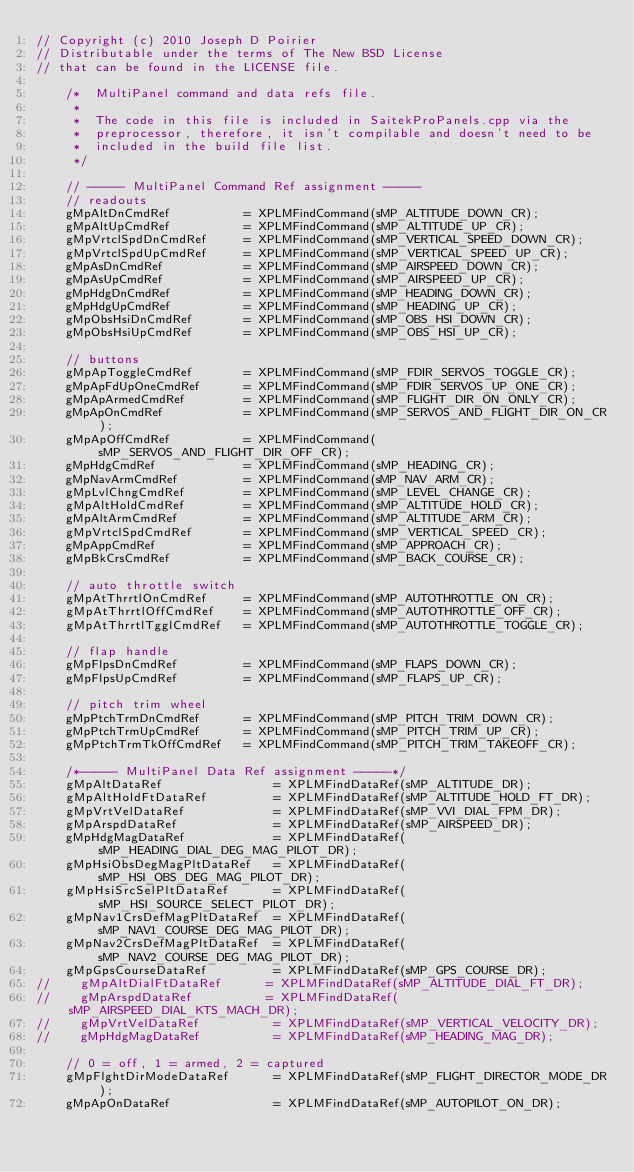<code> <loc_0><loc_0><loc_500><loc_500><_C++_>// Copyright (c) 2010 Joseph D Poirier
// Distributable under the terms of The New BSD License
// that can be found in the LICENSE file.

    /*  MultiPanel command and data refs file.
     *
     *  The code in this file is included in SaitekProPanels.cpp via the
     *  preprocessor, therefore, it isn't compilable and doesn't need to be
     *  included in the build file list.
     */

    // ----- MultiPanel Command Ref assignment -----
    // readouts
    gMpAltDnCmdRef          = XPLMFindCommand(sMP_ALTITUDE_DOWN_CR);
    gMpAltUpCmdRef          = XPLMFindCommand(sMP_ALTITUDE_UP_CR);
    gMpVrtclSpdDnCmdRef     = XPLMFindCommand(sMP_VERTICAL_SPEED_DOWN_CR);
    gMpVrtclSpdUpCmdRef     = XPLMFindCommand(sMP_VERTICAL_SPEED_UP_CR);
    gMpAsDnCmdRef           = XPLMFindCommand(sMP_AIRSPEED_DOWN_CR);
    gMpAsUpCmdRef           = XPLMFindCommand(sMP_AIRSPEED_UP_CR);
    gMpHdgDnCmdRef          = XPLMFindCommand(sMP_HEADING_DOWN_CR);
    gMpHdgUpCmdRef          = XPLMFindCommand(sMP_HEADING_UP_CR);
    gMpObsHsiDnCmdRef       = XPLMFindCommand(sMP_OBS_HSI_DOWN_CR);
    gMpObsHsiUpCmdRef       = XPLMFindCommand(sMP_OBS_HSI_UP_CR);

    // buttons
    gMpApToggleCmdRef       = XPLMFindCommand(sMP_FDIR_SERVOS_TOGGLE_CR);
    gMpApFdUpOneCmdRef      = XPLMFindCommand(sMP_FDIR_SERVOS_UP_ONE_CR);
    gMpApArmedCmdRef        = XPLMFindCommand(sMP_FLIGHT_DIR_ON_ONLY_CR);
    gMpApOnCmdRef           = XPLMFindCommand(sMP_SERVOS_AND_FLIGHT_DIR_ON_CR);
    gMpApOffCmdRef          = XPLMFindCommand(sMP_SERVOS_AND_FLIGHT_DIR_OFF_CR);
    gMpHdgCmdRef            = XPLMFindCommand(sMP_HEADING_CR);
    gMpNavArmCmdRef         = XPLMFindCommand(sMP_NAV_ARM_CR);
    gMpLvlChngCmdRef        = XPLMFindCommand(sMP_LEVEL_CHANGE_CR);
    gMpAltHoldCmdRef        = XPLMFindCommand(sMP_ALTITUDE_HOLD_CR);
    gMpAltArmCmdRef         = XPLMFindCommand(sMP_ALTITUDE_ARM_CR);
    gMpVrtclSpdCmdRef       = XPLMFindCommand(sMP_VERTICAL_SPEED_CR);
    gMpAppCmdRef            = XPLMFindCommand(sMP_APPROACH_CR);
    gMpBkCrsCmdRef          = XPLMFindCommand(sMP_BACK_COURSE_CR);

    // auto throttle switch
    gMpAtThrrtlOnCmdRef     = XPLMFindCommand(sMP_AUTOTHROTTLE_ON_CR);
    gMpAtThrrtlOffCmdRef    = XPLMFindCommand(sMP_AUTOTHROTTLE_OFF_CR);
    gMpAtThrrtlTgglCmdRef   = XPLMFindCommand(sMP_AUTOTHROTTLE_TOGGLE_CR);

    // flap handle
    gMpFlpsDnCmdRef         = XPLMFindCommand(sMP_FLAPS_DOWN_CR);
    gMpFlpsUpCmdRef         = XPLMFindCommand(sMP_FLAPS_UP_CR);

    // pitch trim wheel
    gMpPtchTrmDnCmdRef      = XPLMFindCommand(sMP_PITCH_TRIM_DOWN_CR);
    gMpPtchTrmUpCmdRef      = XPLMFindCommand(sMP_PITCH_TRIM_UP_CR);
    gMpPtchTrmTkOffCmdRef   = XPLMFindCommand(sMP_PITCH_TRIM_TAKEOFF_CR);

    /*----- MultiPanel Data Ref assignment -----*/
    gMpAltDataRef               = XPLMFindDataRef(sMP_ALTITUDE_DR);
    gMpAltHoldFtDataRef         = XPLMFindDataRef(sMP_ALTITUDE_HOLD_FT_DR);
    gMpVrtVelDataRef            = XPLMFindDataRef(sMP_VVI_DIAL_FPM_DR);
    gMpArspdDataRef             = XPLMFindDataRef(sMP_AIRSPEED_DR);
    gMpHdgMagDataRef            = XPLMFindDataRef(sMP_HEADING_DIAL_DEG_MAG_PILOT_DR);
    gMpHsiObsDegMagPltDataRef   = XPLMFindDataRef(sMP_HSI_OBS_DEG_MAG_PILOT_DR);
    gMpHsiSrcSelPltDataRef      = XPLMFindDataRef(sMP_HSI_SOURCE_SELECT_PILOT_DR);
    gMpNav1CrsDefMagPltDataRef  = XPLMFindDataRef(sMP_NAV1_COURSE_DEG_MAG_PILOT_DR);
    gMpNav2CrsDefMagPltDataRef  = XPLMFindDataRef(sMP_NAV2_COURSE_DEG_MAG_PILOT_DR);
    gMpGpsCourseDataRef         = XPLMFindDataRef(sMP_GPS_COURSE_DR);
//    gMpAltDialFtDataRef      = XPLMFindDataRef(sMP_ALTITUDE_DIAL_FT_DR);
//    gMpArspdDataRef          = XPLMFindDataRef(sMP_AIRSPEED_DIAL_KTS_MACH_DR);
//    gMpVrtVelDataRef          = XPLMFindDataRef(sMP_VERTICAL_VELOCITY_DR);
//    gMpHdgMagDataRef          = XPLMFindDataRef(sMP_HEADING_MAG_DR);

    // 0 = off, 1 = armed, 2 = captured
    gMpFlghtDirModeDataRef      = XPLMFindDataRef(sMP_FLIGHT_DIRECTOR_MODE_DR);
    gMpApOnDataRef              = XPLMFindDataRef(sMP_AUTOPILOT_ON_DR);</code> 